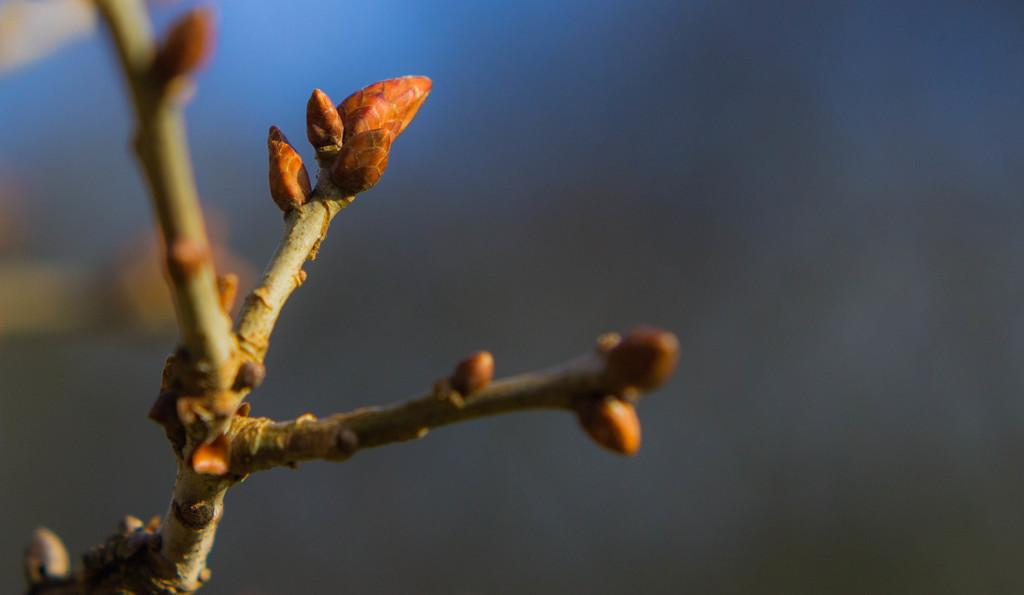What can be seen on the left side of the image? There are stems with buds on the left side of the image. How would you describe the background of the image? The background of the image is blurred. What type of shame can be seen in the image? There is no shame present in the image; it features stems with buds and a blurred background. 